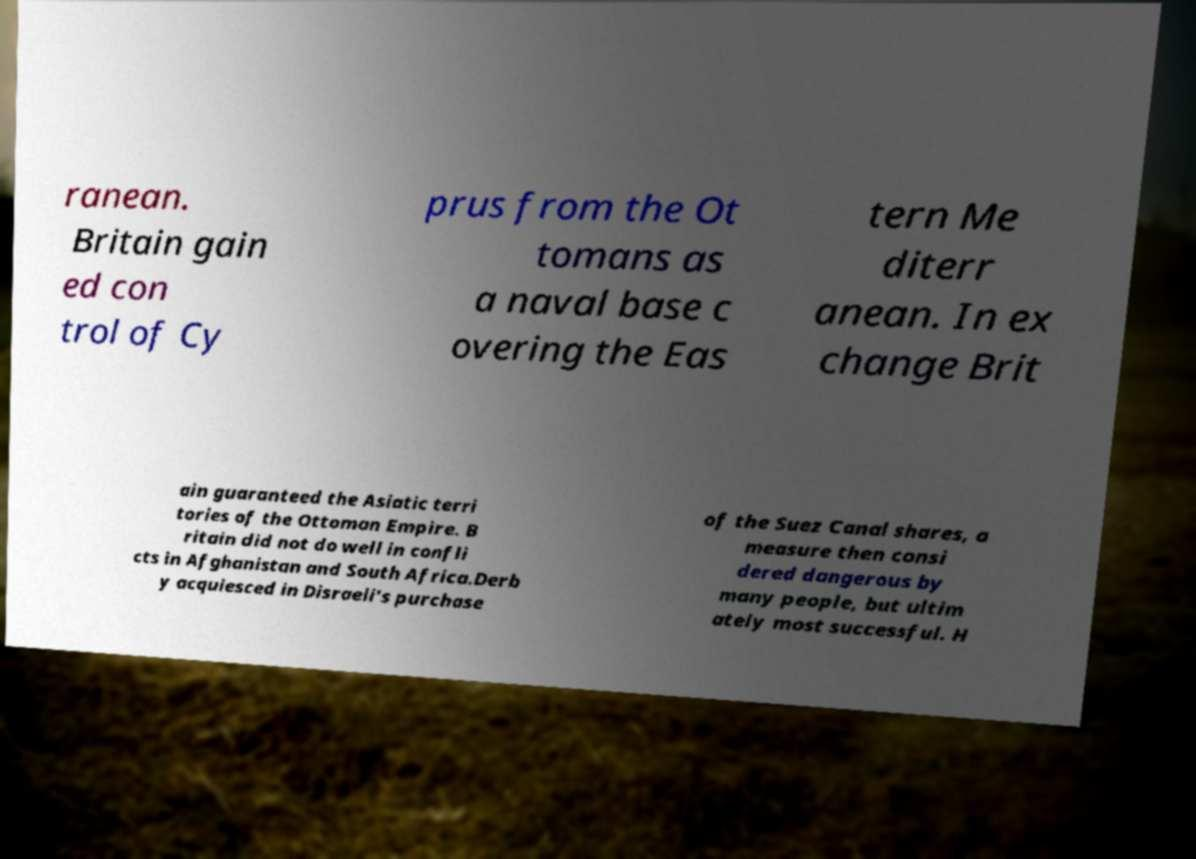There's text embedded in this image that I need extracted. Can you transcribe it verbatim? ranean. Britain gain ed con trol of Cy prus from the Ot tomans as a naval base c overing the Eas tern Me diterr anean. In ex change Brit ain guaranteed the Asiatic terri tories of the Ottoman Empire. B ritain did not do well in confli cts in Afghanistan and South Africa.Derb y acquiesced in Disraeli's purchase of the Suez Canal shares, a measure then consi dered dangerous by many people, but ultim ately most successful. H 